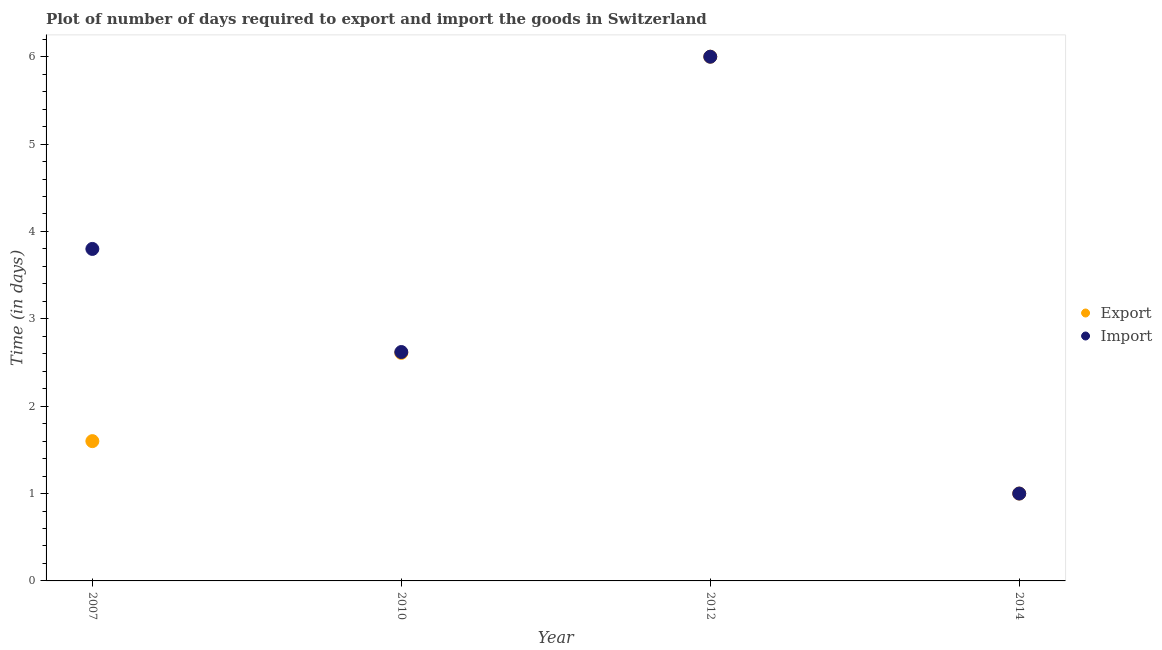What is the time required to import in 2014?
Keep it short and to the point. 1. What is the total time required to import in the graph?
Make the answer very short. 13.42. What is the difference between the time required to export in 2010 and that in 2014?
Make the answer very short. 1.61. What is the difference between the time required to export in 2007 and the time required to import in 2014?
Your response must be concise. 0.6. What is the average time required to export per year?
Make the answer very short. 2.8. In the year 2007, what is the difference between the time required to import and time required to export?
Provide a short and direct response. 2.2. In how many years, is the time required to export greater than 2.2 days?
Your answer should be very brief. 2. What is the ratio of the time required to export in 2010 to that in 2014?
Ensure brevity in your answer.  2.61. Is the difference between the time required to export in 2007 and 2010 greater than the difference between the time required to import in 2007 and 2010?
Your response must be concise. No. What is the difference between the highest and the second highest time required to import?
Offer a terse response. 2.2. In how many years, is the time required to export greater than the average time required to export taken over all years?
Provide a succinct answer. 1. Is the sum of the time required to export in 2007 and 2012 greater than the maximum time required to import across all years?
Make the answer very short. Yes. Is the time required to export strictly greater than the time required to import over the years?
Provide a succinct answer. No. Is the time required to export strictly less than the time required to import over the years?
Provide a succinct answer. No. How many dotlines are there?
Your answer should be very brief. 2. What is the difference between two consecutive major ticks on the Y-axis?
Give a very brief answer. 1. Does the graph contain any zero values?
Offer a terse response. No. Where does the legend appear in the graph?
Offer a terse response. Center right. How many legend labels are there?
Your answer should be very brief. 2. How are the legend labels stacked?
Your response must be concise. Vertical. What is the title of the graph?
Your answer should be very brief. Plot of number of days required to export and import the goods in Switzerland. What is the label or title of the Y-axis?
Offer a terse response. Time (in days). What is the Time (in days) in Export in 2007?
Offer a very short reply. 1.6. What is the Time (in days) in Import in 2007?
Your response must be concise. 3.8. What is the Time (in days) in Export in 2010?
Offer a terse response. 2.61. What is the Time (in days) of Import in 2010?
Offer a very short reply. 2.62. What is the Time (in days) in Import in 2012?
Offer a very short reply. 6. What is the Time (in days) of Import in 2014?
Keep it short and to the point. 1. Across all years, what is the maximum Time (in days) in Export?
Make the answer very short. 6. What is the total Time (in days) of Export in the graph?
Provide a short and direct response. 11.21. What is the total Time (in days) in Import in the graph?
Provide a short and direct response. 13.42. What is the difference between the Time (in days) of Export in 2007 and that in 2010?
Give a very brief answer. -1.01. What is the difference between the Time (in days) in Import in 2007 and that in 2010?
Give a very brief answer. 1.18. What is the difference between the Time (in days) of Export in 2007 and that in 2012?
Make the answer very short. -4.4. What is the difference between the Time (in days) of Export in 2010 and that in 2012?
Offer a very short reply. -3.39. What is the difference between the Time (in days) in Import in 2010 and that in 2012?
Offer a terse response. -3.38. What is the difference between the Time (in days) in Export in 2010 and that in 2014?
Provide a succinct answer. 1.61. What is the difference between the Time (in days) of Import in 2010 and that in 2014?
Keep it short and to the point. 1.62. What is the difference between the Time (in days) of Export in 2007 and the Time (in days) of Import in 2010?
Provide a succinct answer. -1.02. What is the difference between the Time (in days) of Export in 2007 and the Time (in days) of Import in 2014?
Your answer should be very brief. 0.6. What is the difference between the Time (in days) in Export in 2010 and the Time (in days) in Import in 2012?
Ensure brevity in your answer.  -3.39. What is the difference between the Time (in days) in Export in 2010 and the Time (in days) in Import in 2014?
Your answer should be compact. 1.61. What is the average Time (in days) of Export per year?
Your response must be concise. 2.8. What is the average Time (in days) in Import per year?
Make the answer very short. 3.35. In the year 2010, what is the difference between the Time (in days) of Export and Time (in days) of Import?
Give a very brief answer. -0.01. What is the ratio of the Time (in days) of Export in 2007 to that in 2010?
Make the answer very short. 0.61. What is the ratio of the Time (in days) of Import in 2007 to that in 2010?
Ensure brevity in your answer.  1.45. What is the ratio of the Time (in days) of Export in 2007 to that in 2012?
Make the answer very short. 0.27. What is the ratio of the Time (in days) in Import in 2007 to that in 2012?
Make the answer very short. 0.63. What is the ratio of the Time (in days) in Export in 2007 to that in 2014?
Give a very brief answer. 1.6. What is the ratio of the Time (in days) in Export in 2010 to that in 2012?
Keep it short and to the point. 0.43. What is the ratio of the Time (in days) of Import in 2010 to that in 2012?
Provide a succinct answer. 0.44. What is the ratio of the Time (in days) of Export in 2010 to that in 2014?
Make the answer very short. 2.61. What is the ratio of the Time (in days) of Import in 2010 to that in 2014?
Keep it short and to the point. 2.62. What is the ratio of the Time (in days) of Export in 2012 to that in 2014?
Provide a succinct answer. 6. What is the ratio of the Time (in days) in Import in 2012 to that in 2014?
Offer a very short reply. 6. What is the difference between the highest and the second highest Time (in days) in Export?
Make the answer very short. 3.39. What is the difference between the highest and the second highest Time (in days) of Import?
Make the answer very short. 2.2. What is the difference between the highest and the lowest Time (in days) of Export?
Offer a terse response. 5. What is the difference between the highest and the lowest Time (in days) in Import?
Give a very brief answer. 5. 